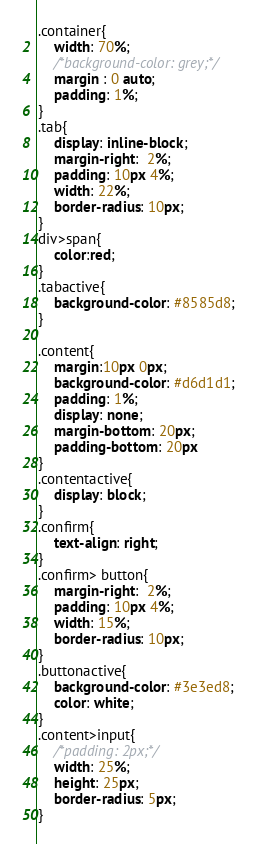<code> <loc_0><loc_0><loc_500><loc_500><_CSS_>.container{
	width: 70%;
	/*background-color: grey;*/
	margin : 0 auto;
	padding: 1%;
}
.tab{
	display: inline-block;
	margin-right:  2%;
	padding: 10px 4%;
	width: 22%;
	border-radius: 10px;
} 
div>span{
	color:red;
}
.tabactive{
	background-color: #8585d8;
}

.content{
	margin:10px 0px;
	background-color: #d6d1d1;
	padding: 1%;
	display: none;
	margin-bottom: 20px;
	padding-bottom: 20px
}
.contentactive{
	display: block;
}
.confirm{
	text-align: right;
}
.confirm> button{
	margin-right:  2%;
	padding: 10px 4%;
	width: 15%;
	border-radius: 10px;
}
.buttonactive{
	background-color: #3e3ed8;
	color: white;
}
.content>input{
	/*padding: 2px;*/
	width: 25%;
	height: 25px;
	border-radius: 5px;
}</code> 